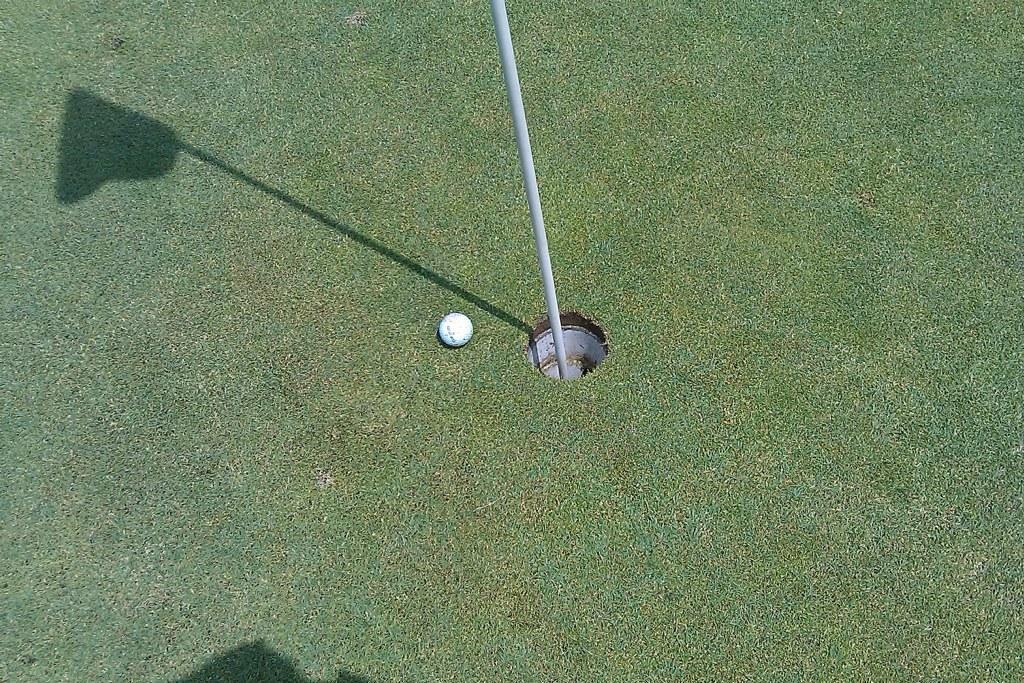Describe this image in one or two sentences. In this picture we can see a golf ball on the grass, beside to the ball we can find a metal rod. 